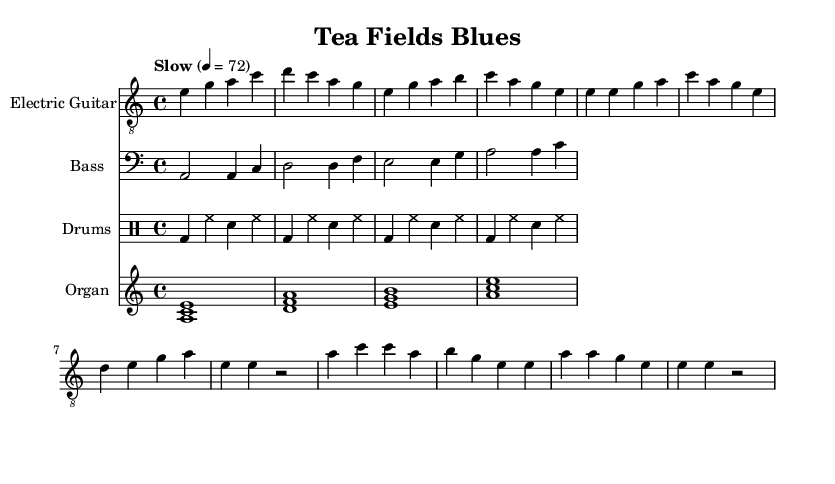What is the key signature of this music? The key signature appears at the beginning of the sheet music, indicated by the sharp or flat symbols. In this case, there is no indication of sharps or flats present, which indicates that the key is A minor.
Answer: A minor What is the time signature? The time signature is indicated at the beginning of the sheet music, typically shown as two numbers stacked vertically. Here it is 4 over 4, which means there are four beats in each measure.
Answer: 4/4 What is the tempo marking of the piece? The tempo marking appears in the header of the sheet music, specifically showing how fast the music should be played. Here, it indicates "Slow" with a metronome marking of 72 beats per minute.
Answer: Slow, 72 How many measures does the electric guitar part have? To determine the number of measures, count the individual measures in the electric guitar part, which are separated by vertical lines. There are a total of 8 measures in the guitar part.
Answer: 8 What instruments are featured in this piece? The piece includes several musical staves which indicate the various instruments involved. They are labeled as Electric Guitar, Bass, Drums, and Organ, representing the four main parts played in this piece.
Answer: Electric Guitar, Bass, Drums, Organ What is the rhythmic pattern of the drums? The drum part includes a series of notations showing the sounds. The pattern comprises a repeating sequence of bass drums and snare and hi-hat strikes in a steady rhythm, evident from the notation provided for four measures.
Answer: Repeating bass, snare, and hi-hat pattern What type of musical genre is represented here? The genre can be determined by the style and characteristics present in the sheet music. Given the specific instruments, tone, and chord progression typical in blues music, it is classified as Electric Blues.
Answer: Electric Blues 